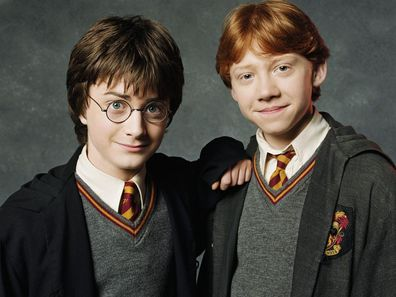Describe an emotional scene this image could represent in the Potter universe. This image could represent an emotional scene where Harry and Ron, having just returned from a daring adventure, share a quiet moment of reflection. They stand in the serene courtyard of Hogwarts, surrounded by the majestic castle and its sprawling grounds. The sun sets in the background, casting a golden hue over their faces. Harry, still wearing his round glasses, looks at Ron with a mixture of relief and gratitude, thankful for their unwavering friendship. Ron meets his gaze with a reassuring smile, silently conveying that no matter the challenges they face, they will always stand by each other. The scene is imbued with a deep sense of camaraderie, loyalty, and the unspoken bond that has grown stronger with every adventure. 